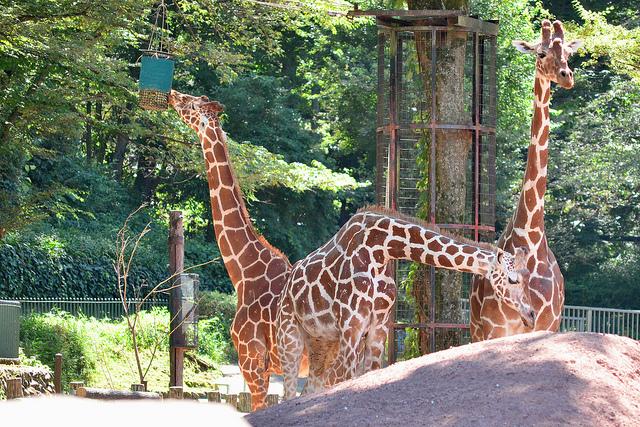How many giraffes are there?
Quick response, please. 3. Can the giraffes reach the trees?
Short answer required. Yes. How many giraffes are there?
Give a very brief answer. 3. 